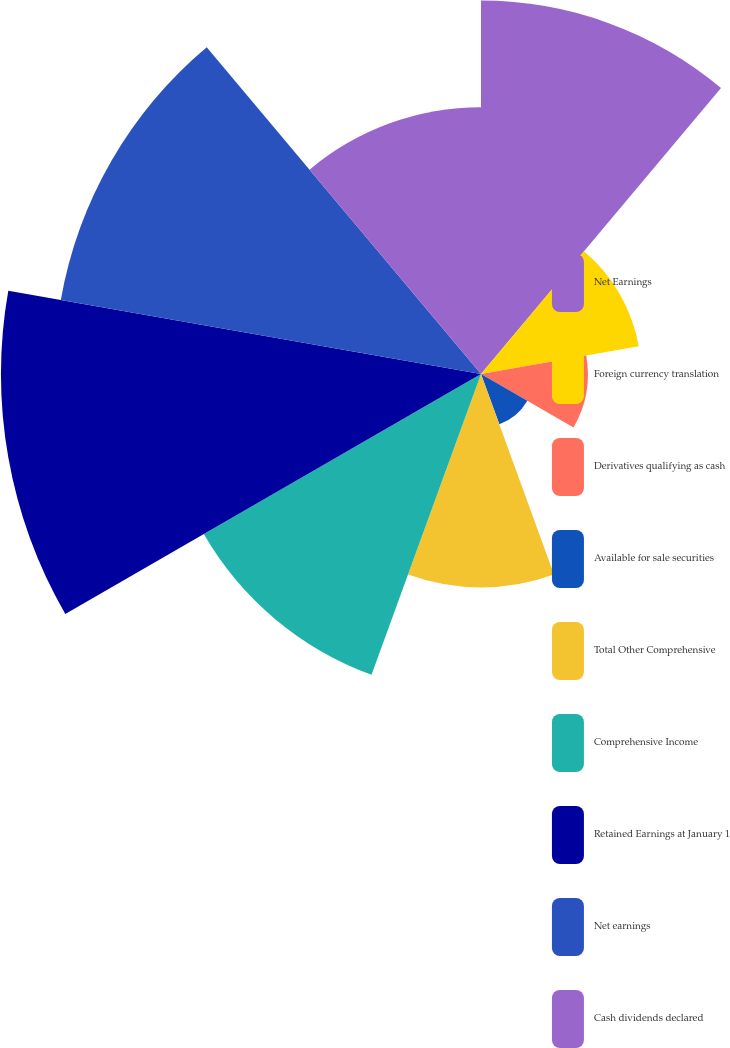Convert chart. <chart><loc_0><loc_0><loc_500><loc_500><pie_chart><fcel>Net Earnings<fcel>Foreign currency translation<fcel>Derivatives qualifying as cash<fcel>Available for sale securities<fcel>Total Other Comprehensive<fcel>Comprehensive Income<fcel>Retained Earnings at January 1<fcel>Net earnings<fcel>Cash dividends declared<nl><fcel>15.55%<fcel>6.67%<fcel>4.45%<fcel>2.23%<fcel>8.89%<fcel>13.33%<fcel>19.99%<fcel>17.77%<fcel>11.11%<nl></chart> 